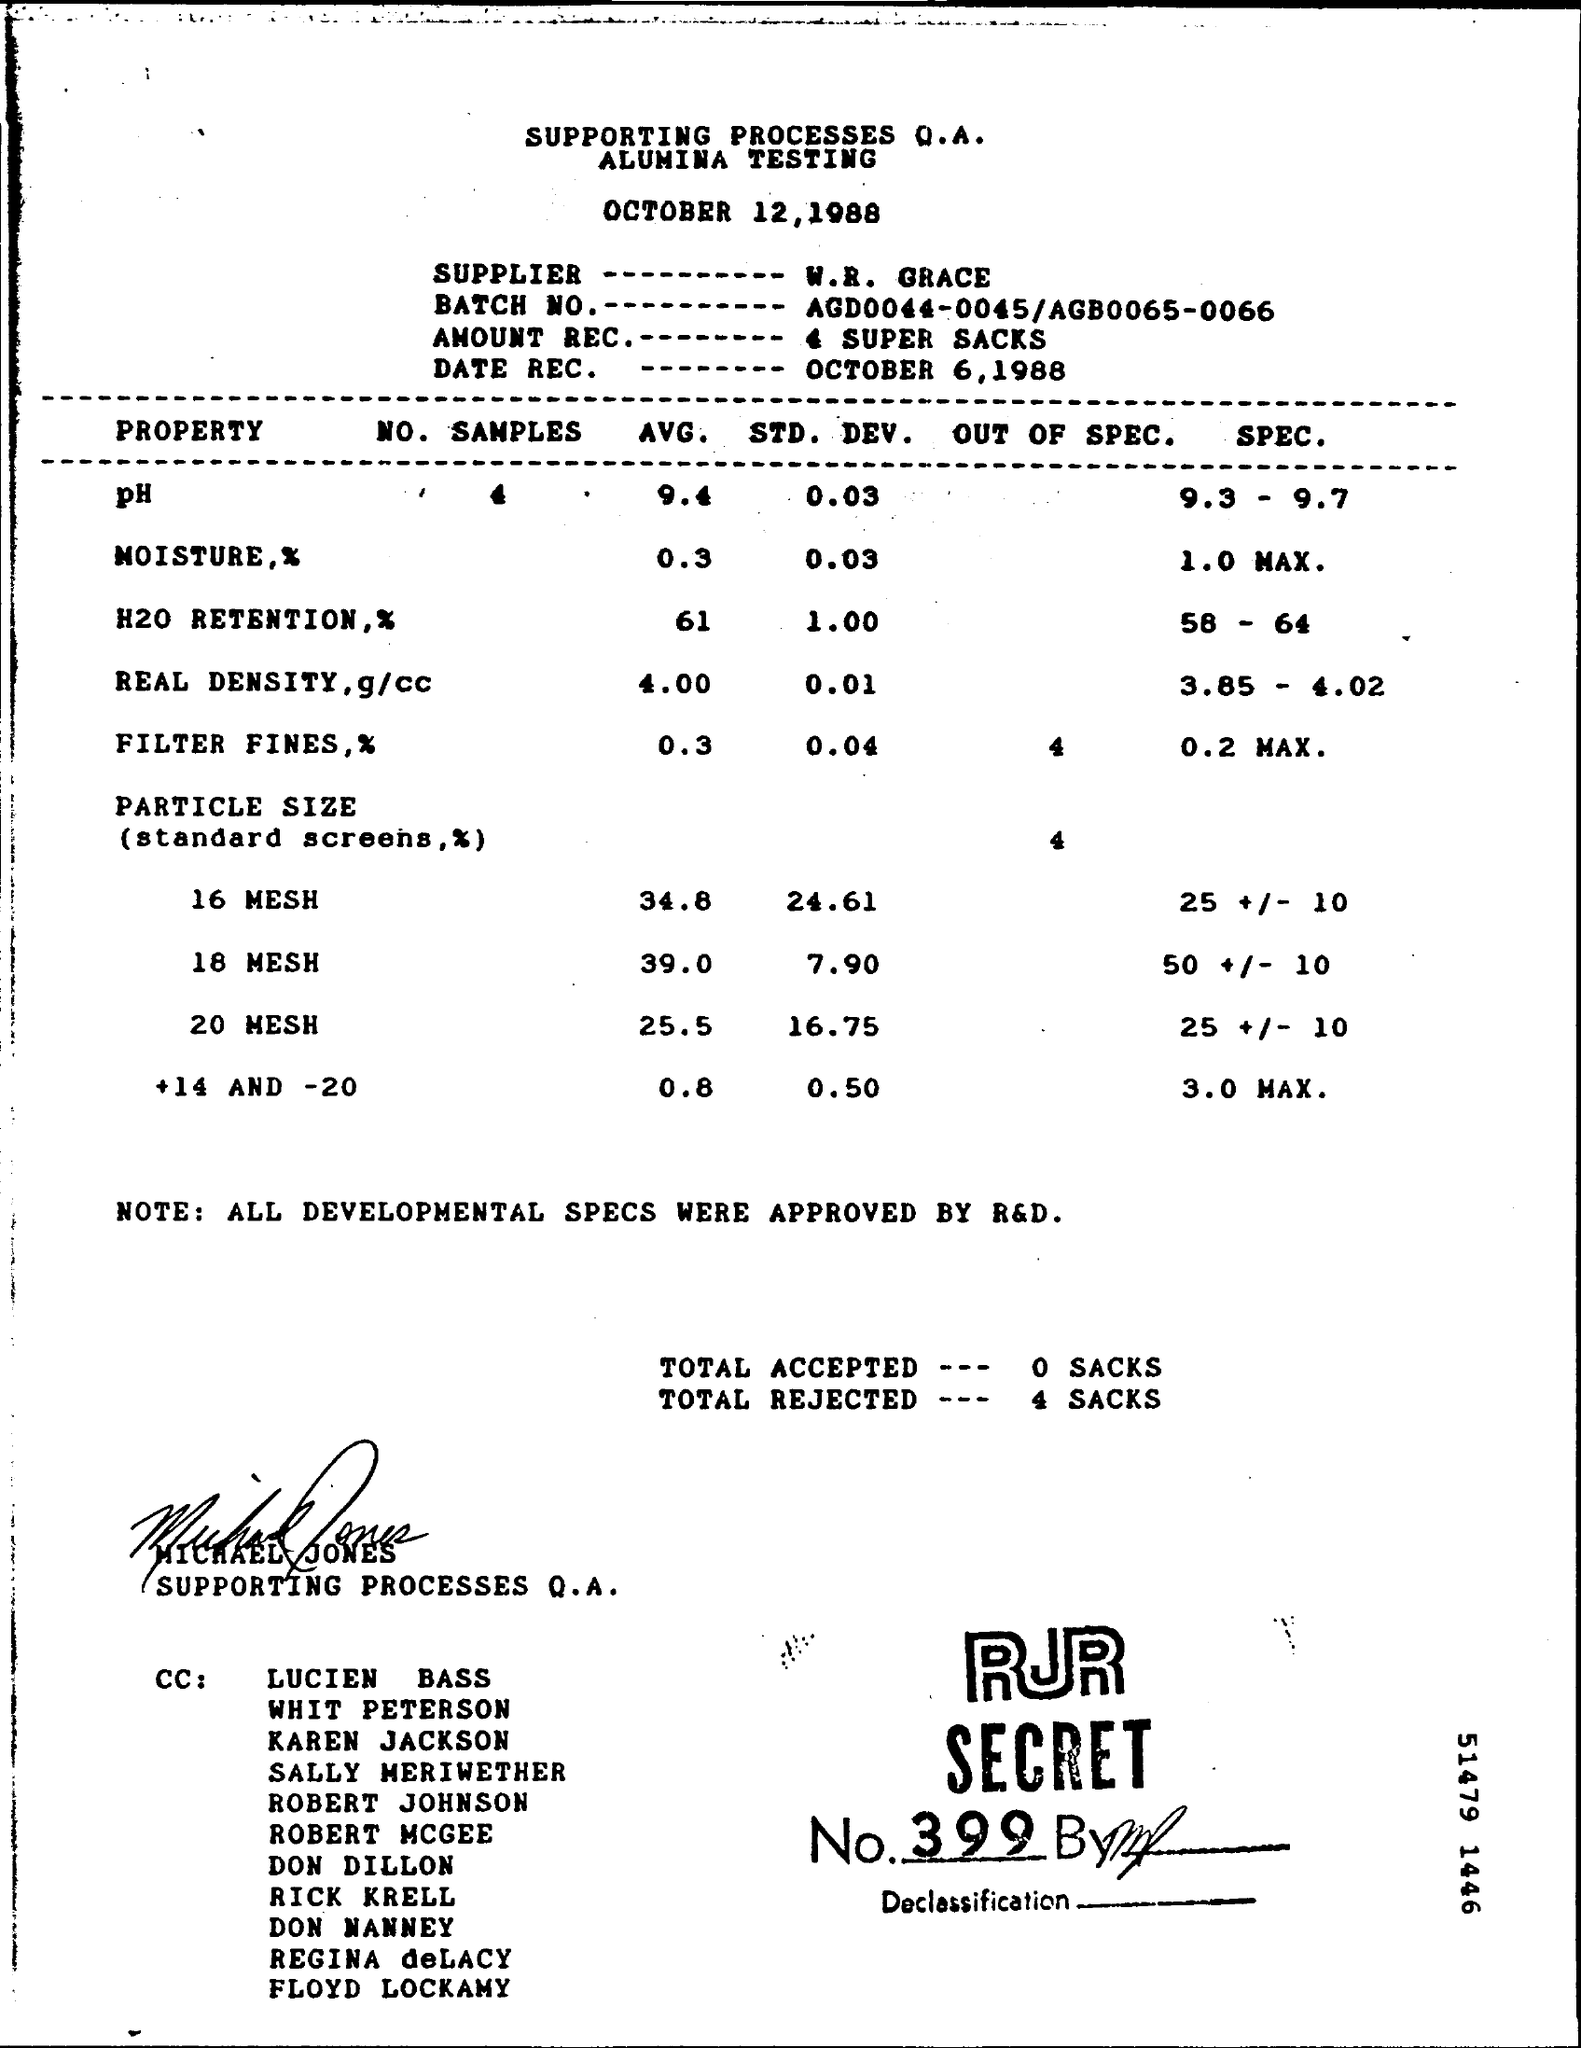What is the avg moisture percentage ?
Your answer should be very brief. 0.3. By whom all the development specs where aproved ?
Your response must be concise. R&D. What is the RJR secret number ?
Your answer should be compact. 399. What is the avg of 16 mesh mentioned in the table ?
Provide a succinct answer. 34.8. 